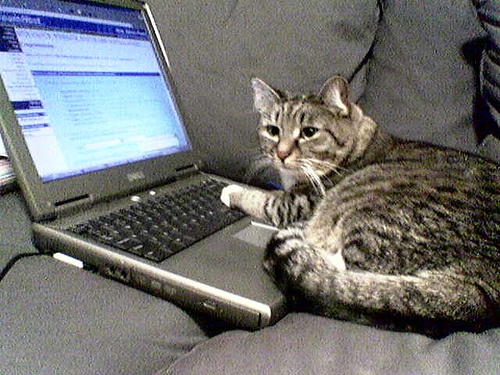Describe the objects in this image and their specific colors. I can see couch in darkblue, gray, and black tones, laptop in darkblue, gray, lightblue, and black tones, and cat in darkblue, black, gray, darkgray, and darkgreen tones in this image. 